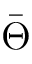<formula> <loc_0><loc_0><loc_500><loc_500>\bar { \Theta }</formula> 